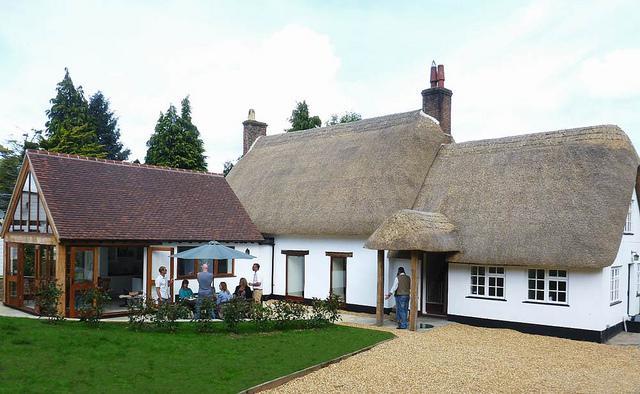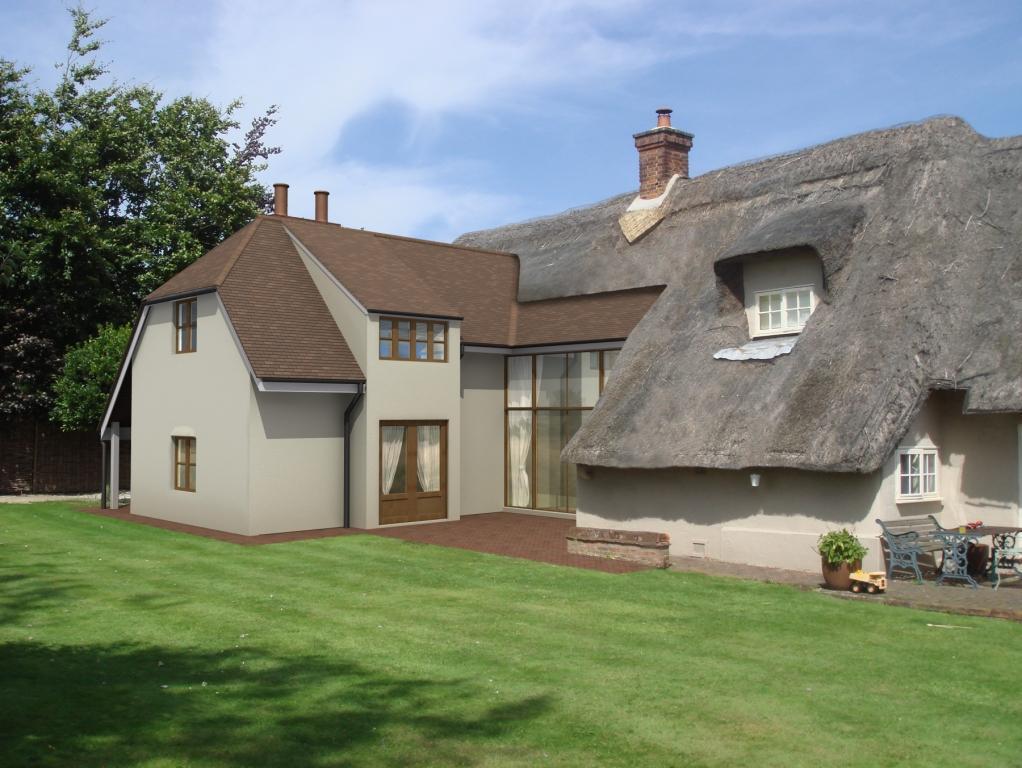The first image is the image on the left, the second image is the image on the right. Analyze the images presented: Is the assertion "The right image is a head-on view of a white building with at least two notches in the roofline to accommodate upper story windows and at least one pyramid roof shape projecting at the front of the house." valid? Answer yes or no. No. 